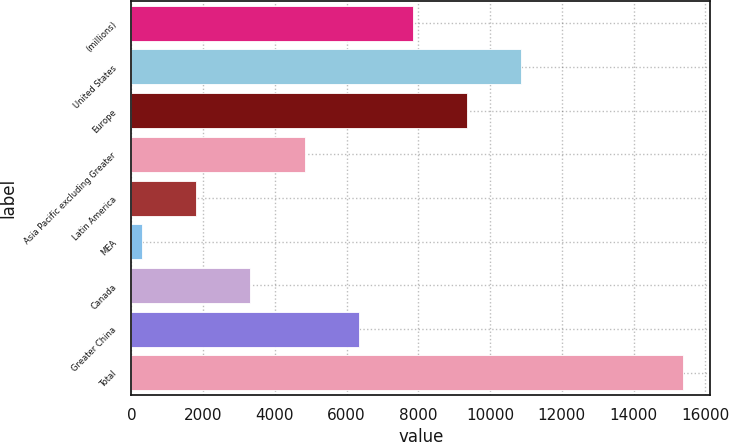Convert chart to OTSL. <chart><loc_0><loc_0><loc_500><loc_500><bar_chart><fcel>(millions)<fcel>United States<fcel>Europe<fcel>Asia Pacific excluding Greater<fcel>Latin America<fcel>MEA<fcel>Canada<fcel>Greater China<fcel>Total<nl><fcel>7838.05<fcel>10849.2<fcel>9343.64<fcel>4826.87<fcel>1815.69<fcel>310.1<fcel>3321.28<fcel>6332.46<fcel>15366<nl></chart> 